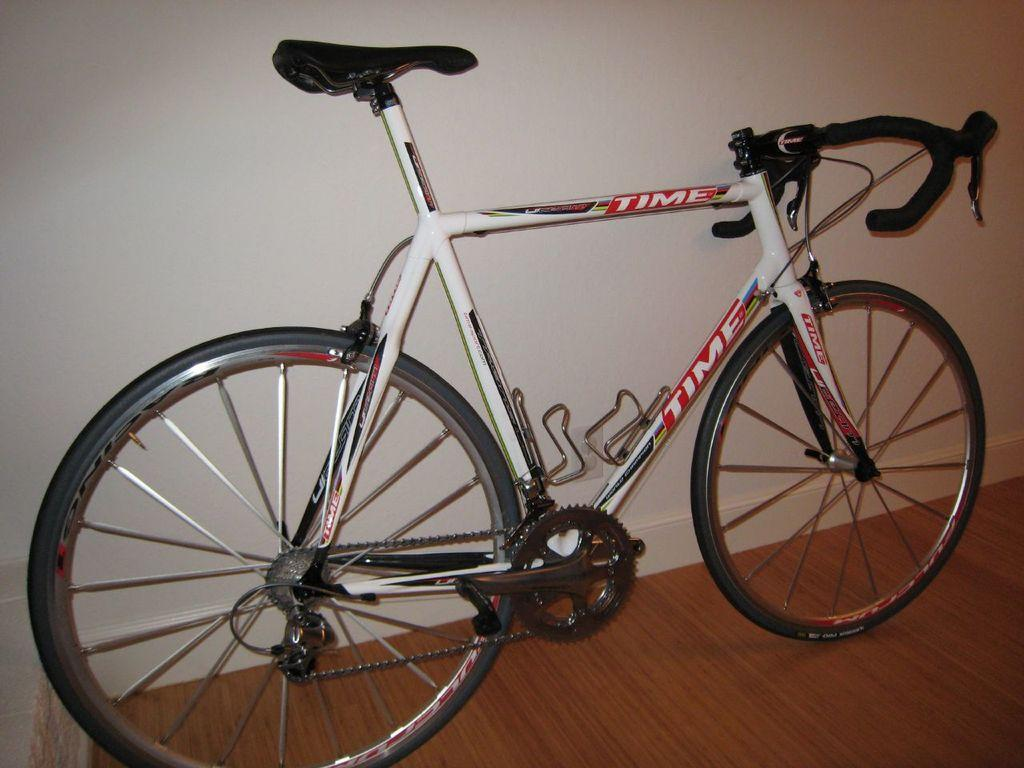What type of vehicle is in the image? There is a white bicycle in the image. What is written on the bicycle? The bicycle has time written on it. Where is the bicycle located in relation to other objects? The bicycle is beside a wall. Where can you find the faucet to wash your hands in the image? There is no faucet present in the image. 